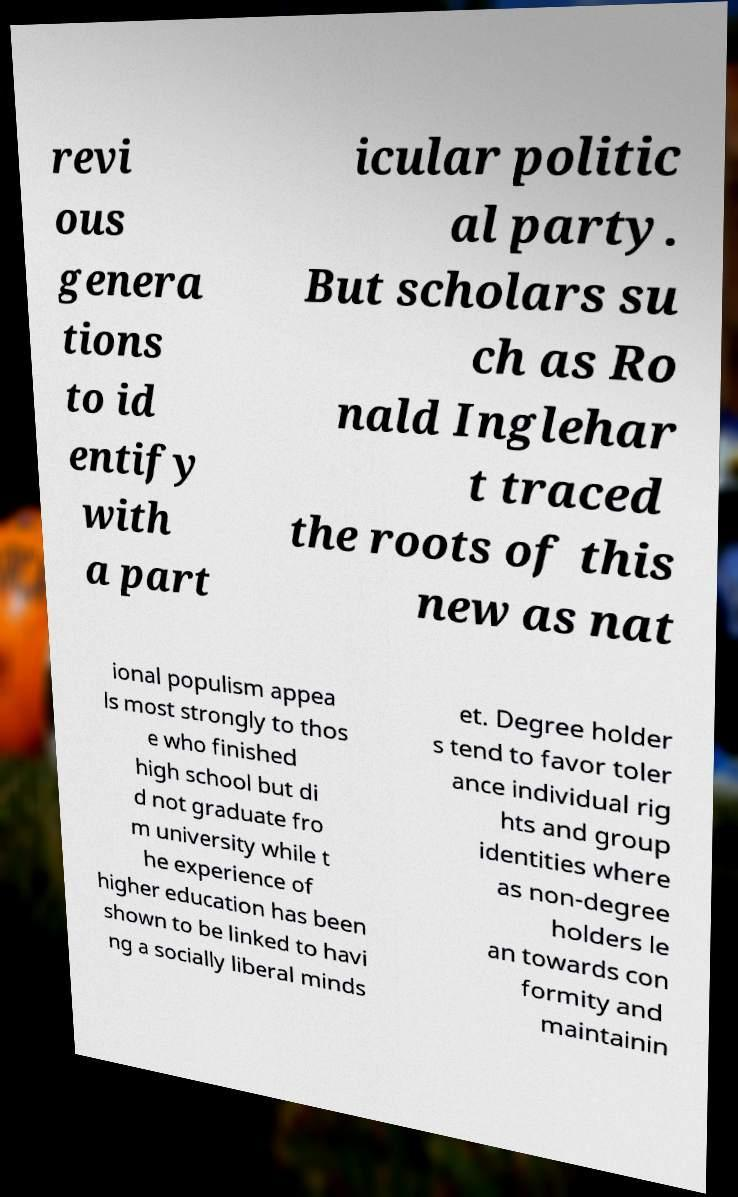Can you accurately transcribe the text from the provided image for me? revi ous genera tions to id entify with a part icular politic al party. But scholars su ch as Ro nald Inglehar t traced the roots of this new as nat ional populism appea ls most strongly to thos e who finished high school but di d not graduate fro m university while t he experience of higher education has been shown to be linked to havi ng a socially liberal minds et. Degree holder s tend to favor toler ance individual rig hts and group identities where as non-degree holders le an towards con formity and maintainin 